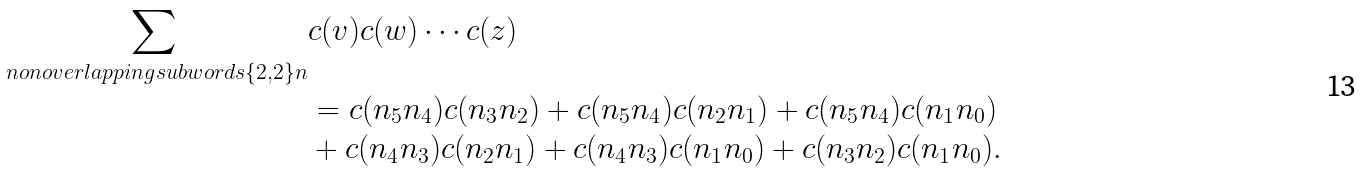<formula> <loc_0><loc_0><loc_500><loc_500>\sum _ { \ n o n o v e r l a p p i n g s u b w o r d s { \{ 2 , 2 \} } { n } } & c ( v ) c ( w ) \cdots c ( z ) \\ & = c ( n _ { 5 } n _ { 4 } ) c ( n _ { 3 } n _ { 2 } ) + c ( n _ { 5 } n _ { 4 } ) c ( n _ { 2 } n _ { 1 } ) + c ( n _ { 5 } n _ { 4 } ) c ( n _ { 1 } n _ { 0 } ) \\ & + c ( n _ { 4 } n _ { 3 } ) c ( n _ { 2 } n _ { 1 } ) + c ( n _ { 4 } n _ { 3 } ) c ( n _ { 1 } n _ { 0 } ) + c ( n _ { 3 } n _ { 2 } ) c ( n _ { 1 } n _ { 0 } ) .</formula> 